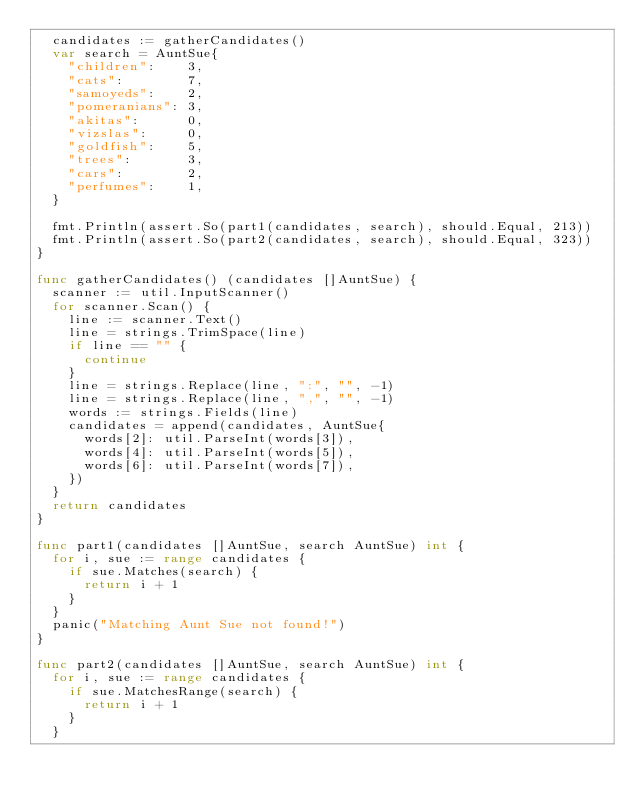<code> <loc_0><loc_0><loc_500><loc_500><_Go_>	candidates := gatherCandidates()
	var search = AuntSue{
		"children":    3,
		"cats":        7,
		"samoyeds":    2,
		"pomeranians": 3,
		"akitas":      0,
		"vizslas":     0,
		"goldfish":    5,
		"trees":       3,
		"cars":        2,
		"perfumes":    1,
	}

	fmt.Println(assert.So(part1(candidates, search), should.Equal, 213))
	fmt.Println(assert.So(part2(candidates, search), should.Equal, 323))
}

func gatherCandidates() (candidates []AuntSue) {
	scanner := util.InputScanner()
	for scanner.Scan() {
		line := scanner.Text()
		line = strings.TrimSpace(line)
		if line == "" {
			continue
		}
		line = strings.Replace(line, ":", "", -1)
		line = strings.Replace(line, ",", "", -1)
		words := strings.Fields(line)
		candidates = append(candidates, AuntSue{
			words[2]: util.ParseInt(words[3]),
			words[4]: util.ParseInt(words[5]),
			words[6]: util.ParseInt(words[7]),
		})
	}
	return candidates
}

func part1(candidates []AuntSue, search AuntSue) int {
	for i, sue := range candidates {
		if sue.Matches(search) {
			return i + 1
		}
	}
	panic("Matching Aunt Sue not found!")
}

func part2(candidates []AuntSue, search AuntSue) int {
	for i, sue := range candidates {
		if sue.MatchesRange(search) {
			return i + 1
		}
	}</code> 